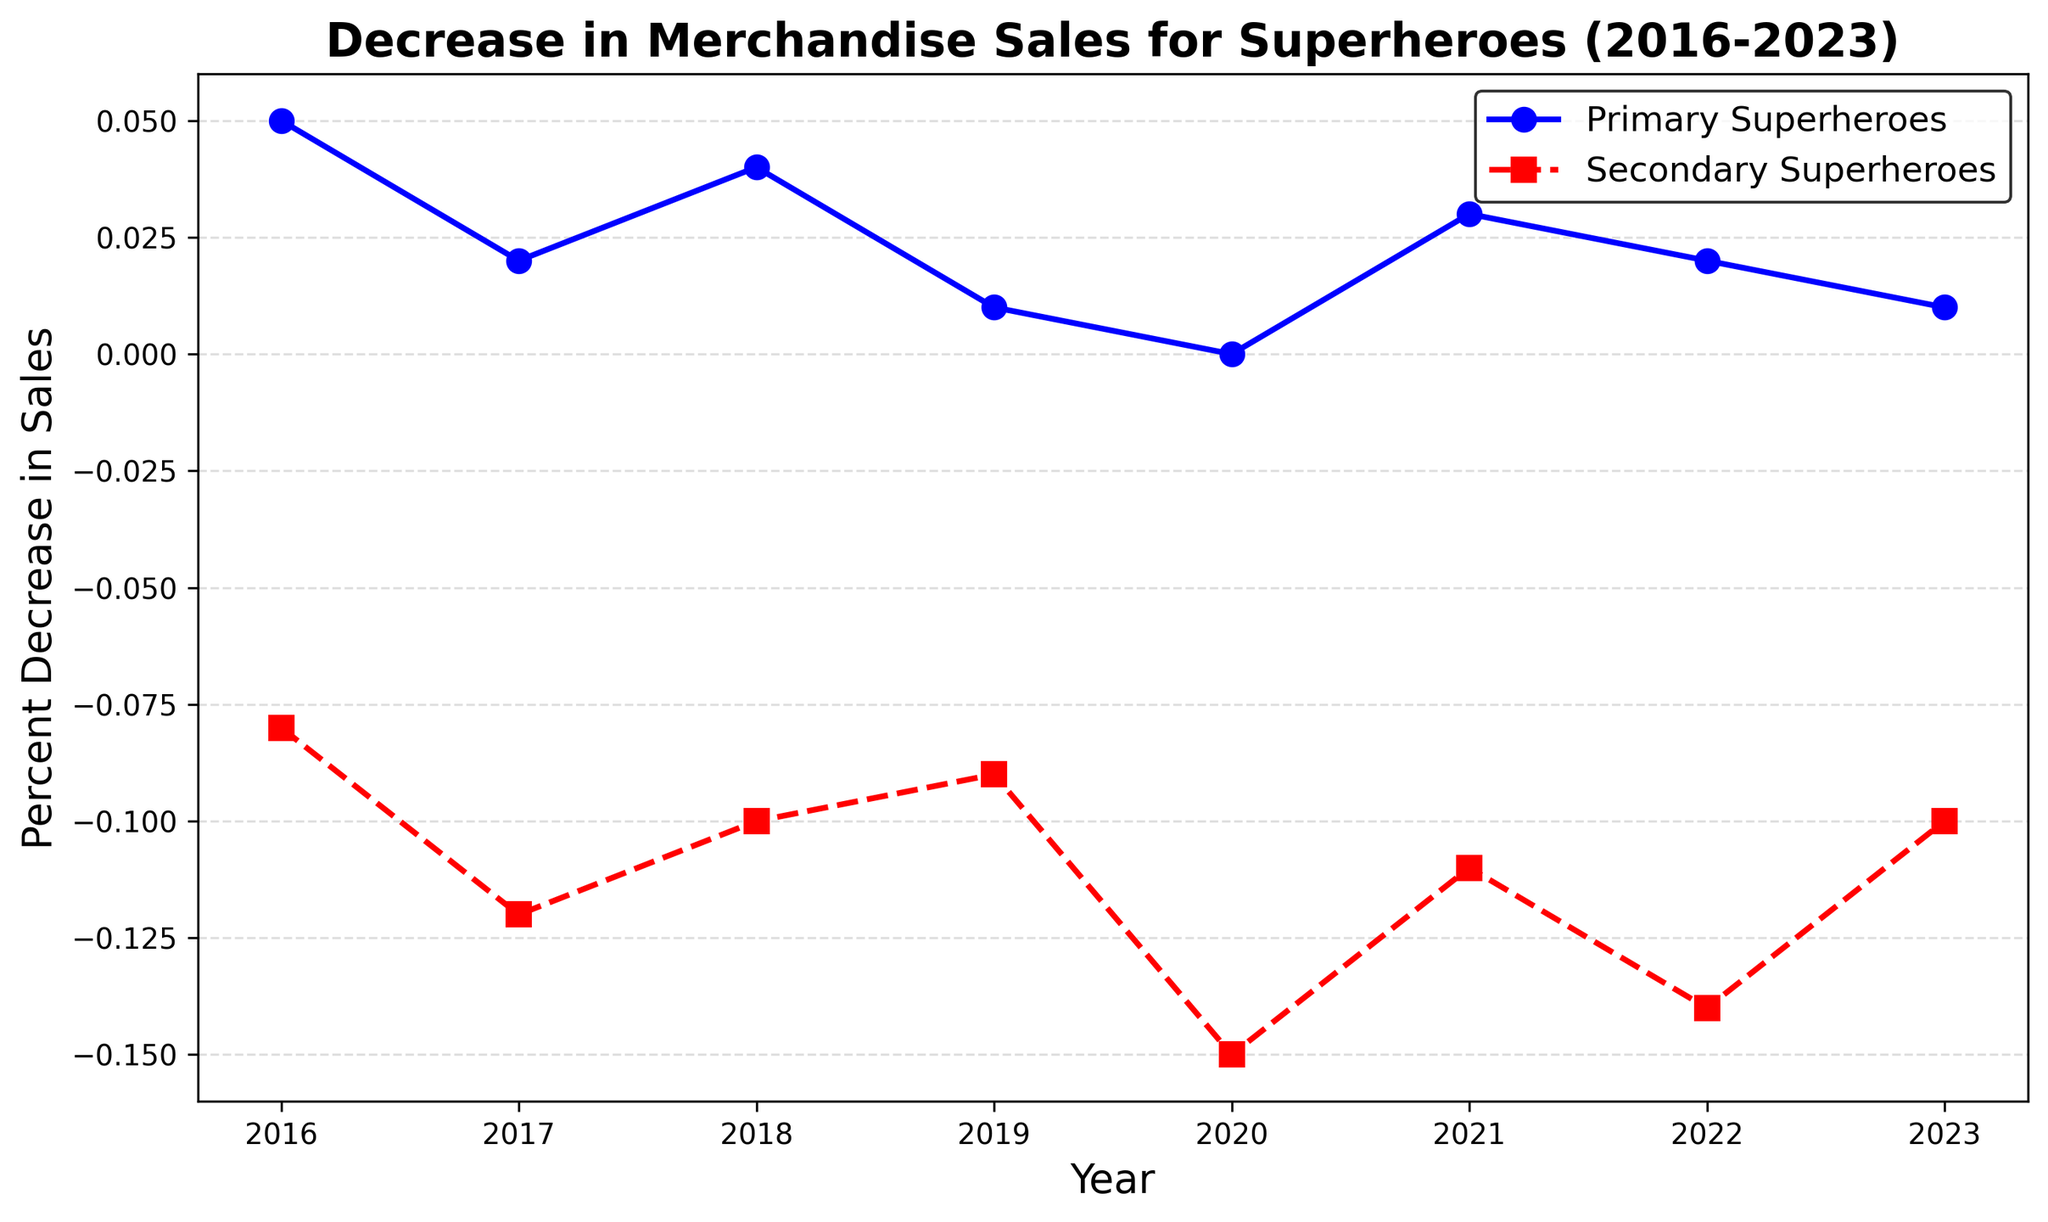What is the overall trend for merchandise sales of Primary Superheroes from 2016 to 2023? The line representing Primary Superheroes shows a fluctuating but generally decreasing trend from 2016 (0.05) to 2023 (0.01).
Answer: Decreasing trend How did the merchandise sales for Secondary Superheroes change from 2020 to 2021? The sales for Secondary Superheroes slightly improved, moving from -0.15 in 2020 to -0.11 in 2021.
Answer: Improved Compare the sales decrease between Primary and Secondary Superheroes in 2022. Which group faced a greater decrease? In 2022, sales for Primary Superheroes decreased by 0.02, while for Secondary Superheroes, it was -0.14. Secondary Superheroes faced a greater decrease.
Answer: Secondary Superheroes Calculate the average decrease in merchandise sales for Primary Superheroes over the years. Sum the decrease values for Primary Superheroes from 2016 to 2023 (0.05 + 0.02 + 0.04 + 0.01 + 0.00 + 0.03 + 0.02 + 0.01) and divide by the number of years (8). The average is 0.225 / 8 = 0.028125.
Answer: 0.028125 In which year was the largest decline in merchandise sales for Secondary Superheroes observed? The largest decline in merchandise sales for Secondary Superheroes was observed in 2020, with a value of -0.15.
Answer: 2020 Are there any years where merchandise sales for Primary Superheroes remained constant or increased? Give an example. Yes, the merchandise sales for Primary Superheroes remained constant in 2020 (0.00) and increased in 2021 (from 0.00 to 0.03).
Answer: 2020, 2021 What is the difference in the sales decrease of Secondary Superheroes between the years 2017 and 2022? The sales decrease for Secondary Superheroes in 2017 was -0.12 and in 2022 it was -0.14. The difference is -0.14 - (-0.12) = -0.02.
Answer: -0.02 Based on the visual attributes, identify which line represents the sales of Secondary Superheroes? The line representing Secondary Superheroes is the dashed red line.
Answer: Dashed red line Which year had the smallest decrease in sales for Primary Superheroes? The smallest decrease for Primary Superheroes occurred in 2020 with a value of 0.00.
Answer: 2020 What is the range of the sales decrease for Secondary Superheroes from 2016 to 2023? The range is calculated by finding the difference between the maximum (-0.08 in 2016) and minimum (-0.15 in 2020) values for Secondary Superheroes. The range is -0.08 - (-0.15) = 0.07.
Answer: 0.07 